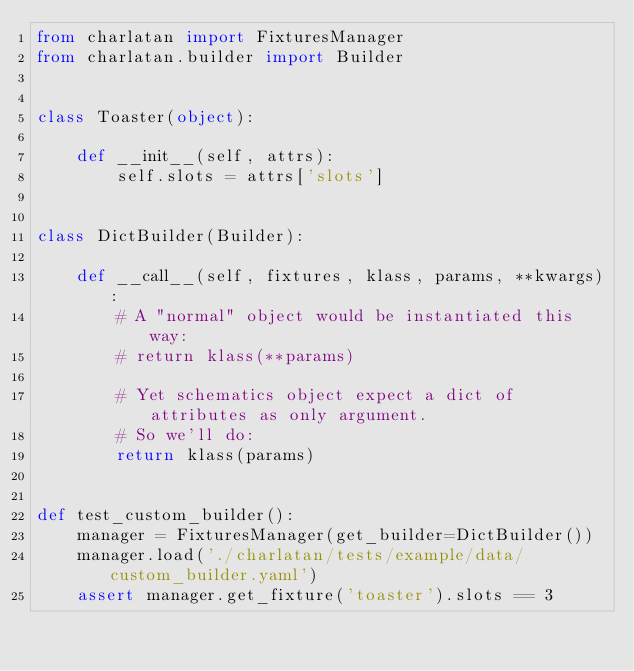<code> <loc_0><loc_0><loc_500><loc_500><_Python_>from charlatan import FixturesManager
from charlatan.builder import Builder


class Toaster(object):

    def __init__(self, attrs):
        self.slots = attrs['slots']


class DictBuilder(Builder):

    def __call__(self, fixtures, klass, params, **kwargs):
        # A "normal" object would be instantiated this way:
        # return klass(**params)

        # Yet schematics object expect a dict of attributes as only argument.
        # So we'll do:
        return klass(params)


def test_custom_builder():
    manager = FixturesManager(get_builder=DictBuilder())
    manager.load('./charlatan/tests/example/data/custom_builder.yaml')
    assert manager.get_fixture('toaster').slots == 3
</code> 